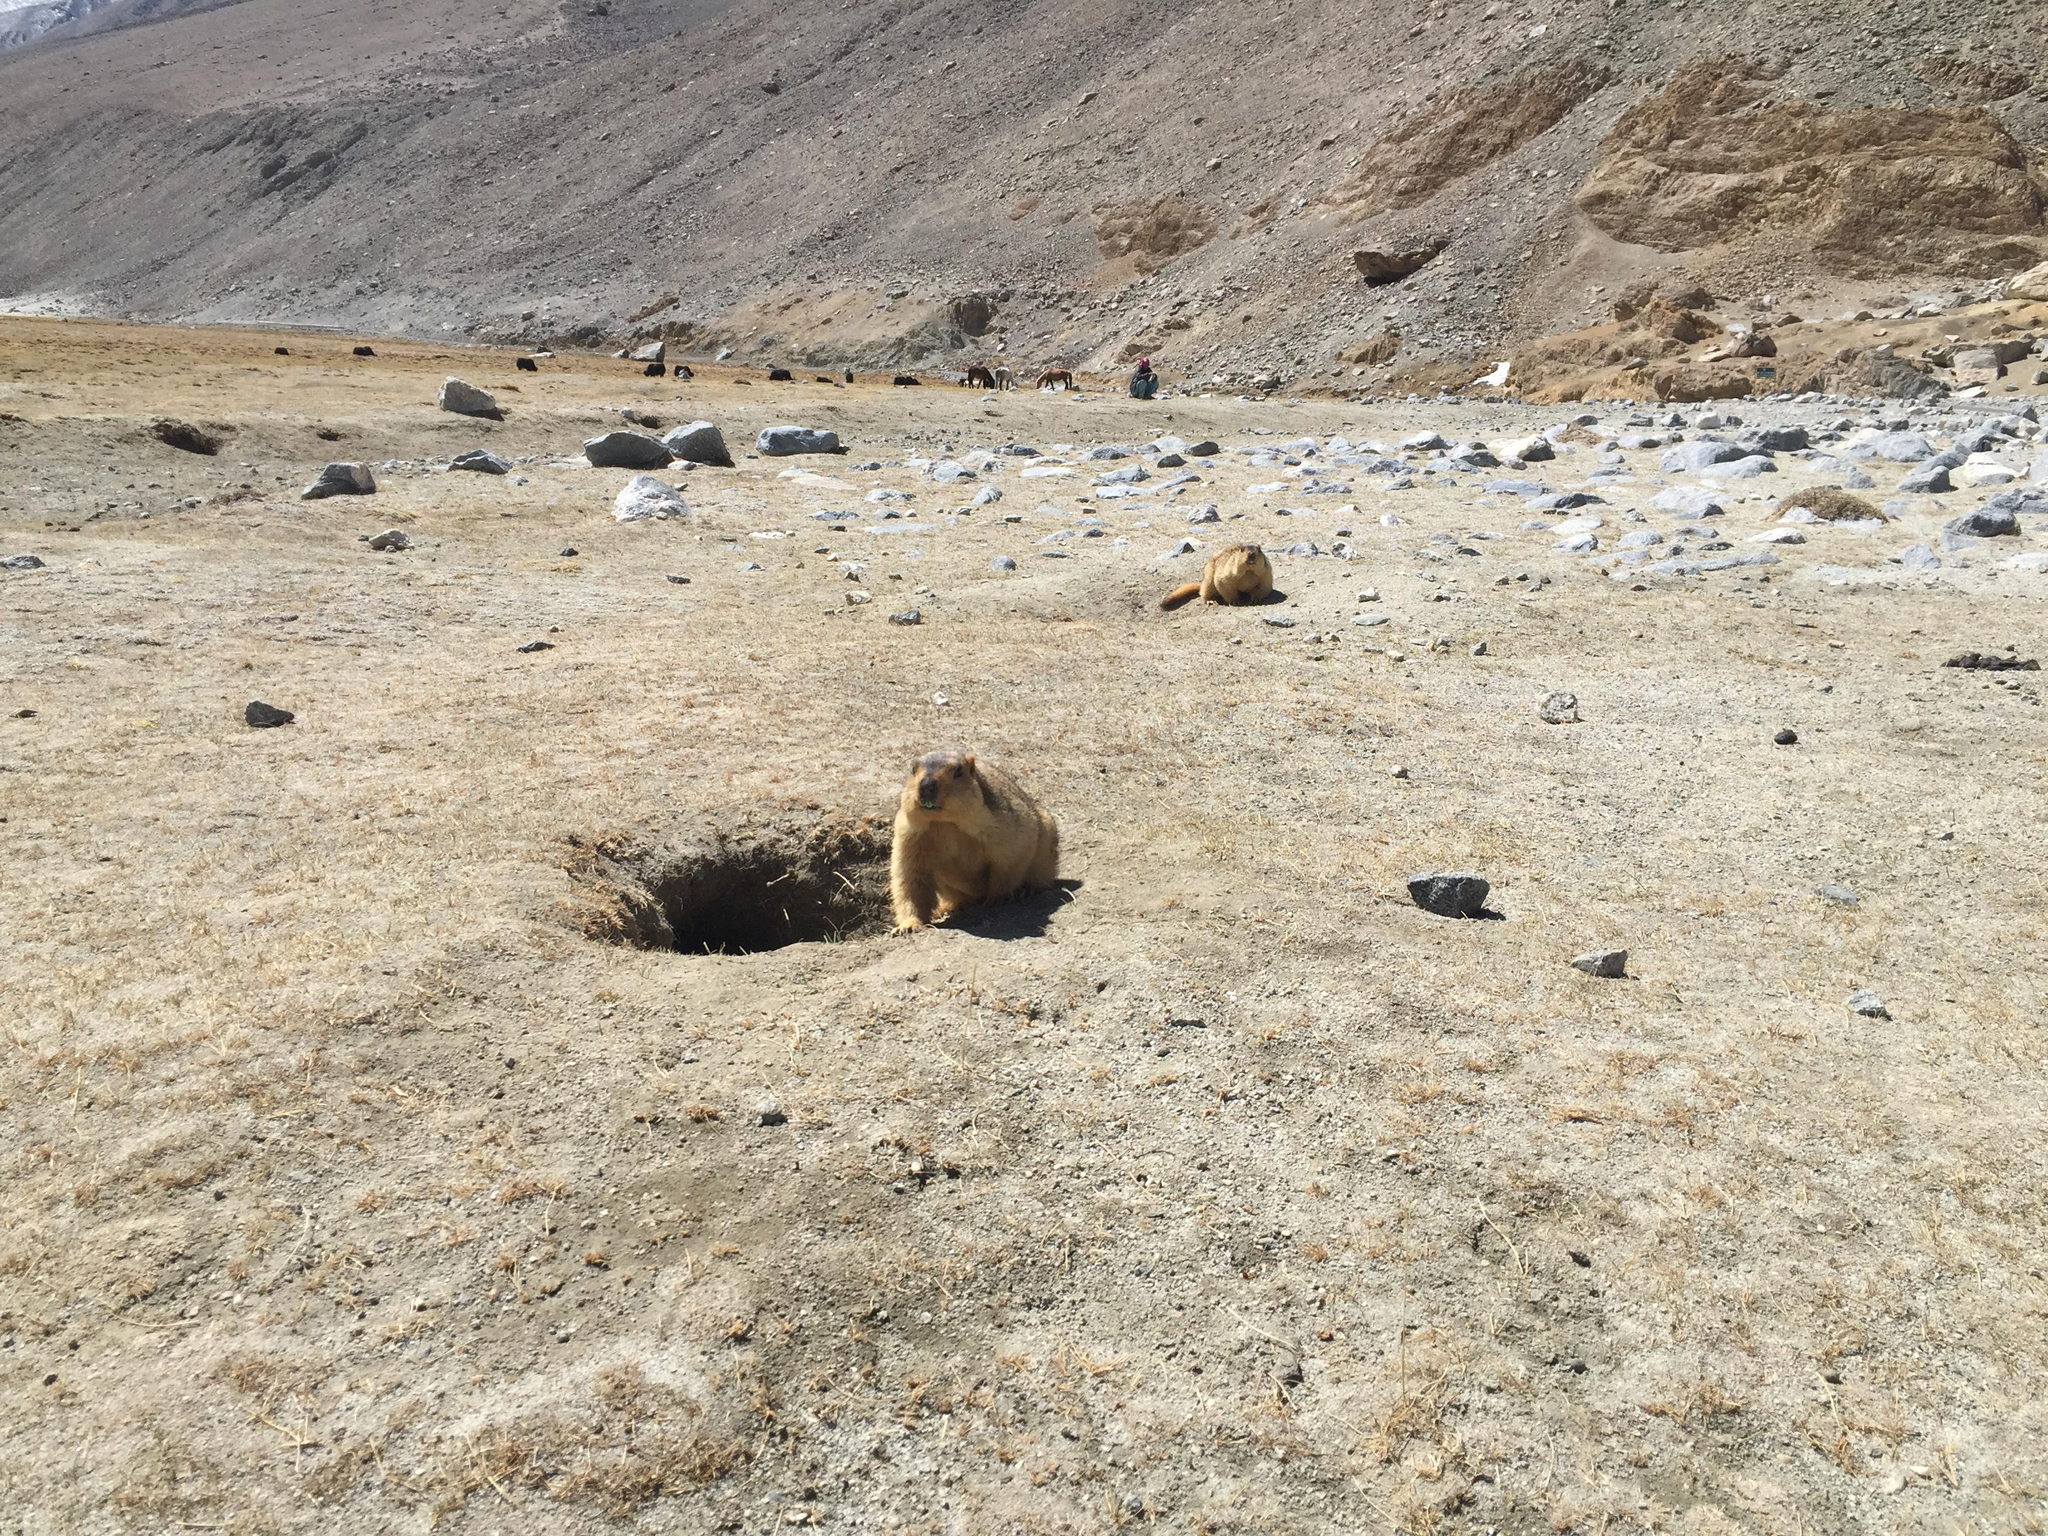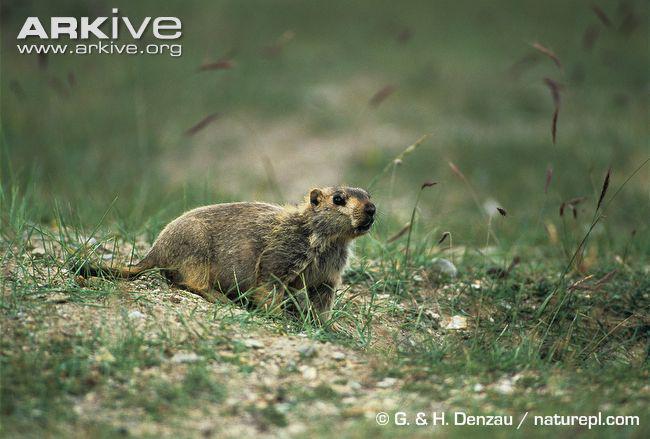The first image is the image on the left, the second image is the image on the right. Assess this claim about the two images: "The combined images include at least two marmots with their heads raised and gazing leftward.". Correct or not? Answer yes or no. No. The first image is the image on the left, the second image is the image on the right. Evaluate the accuracy of this statement regarding the images: "There are more animals in the image on the left.". Is it true? Answer yes or no. Yes. 